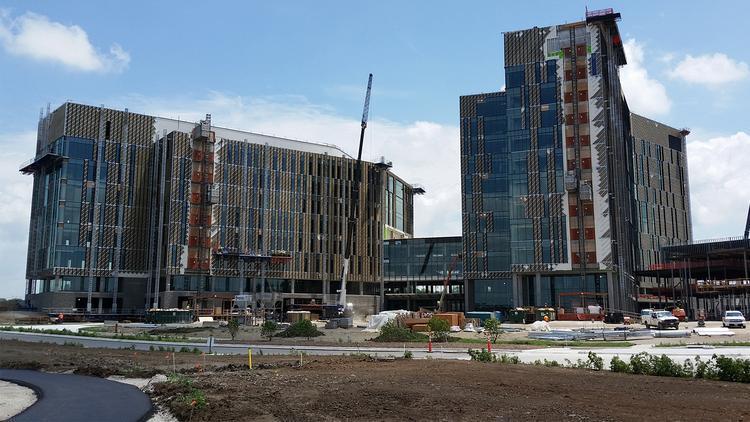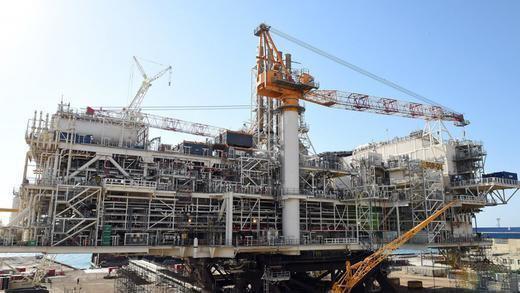The first image is the image on the left, the second image is the image on the right. Assess this claim about the two images: "In one image there are at least two cranes.". Correct or not? Answer yes or no. Yes. 